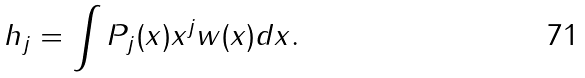<formula> <loc_0><loc_0><loc_500><loc_500>h _ { j } = \int P _ { j } ( x ) x ^ { j } w ( x ) d x .</formula> 